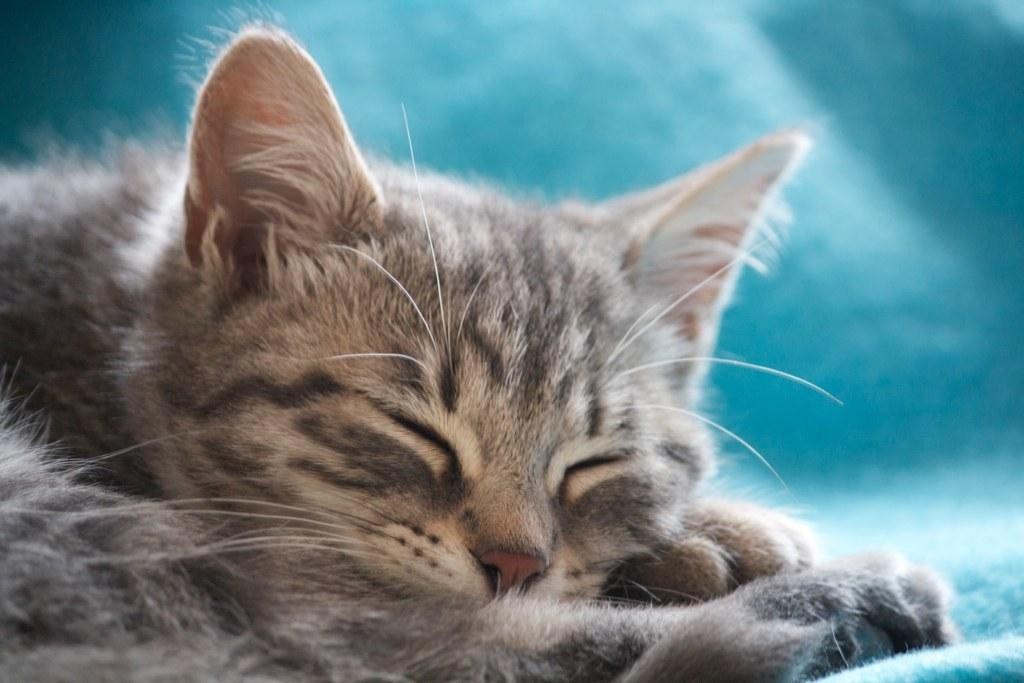What type of animal is present in the image? There is a cat in the image. What is the cat doing in the image? The cat is sleeping in the image. On what surface is the cat resting? The cat is on a cloth in the image. Where is the cook working in the image? There is no cook present in the image; it features a sleeping cat on a cloth. What type of patch can be seen on the cat's fur in the image? There is no patch visible on the cat's fur in the image; it is simply a sleeping cat on a cloth. 